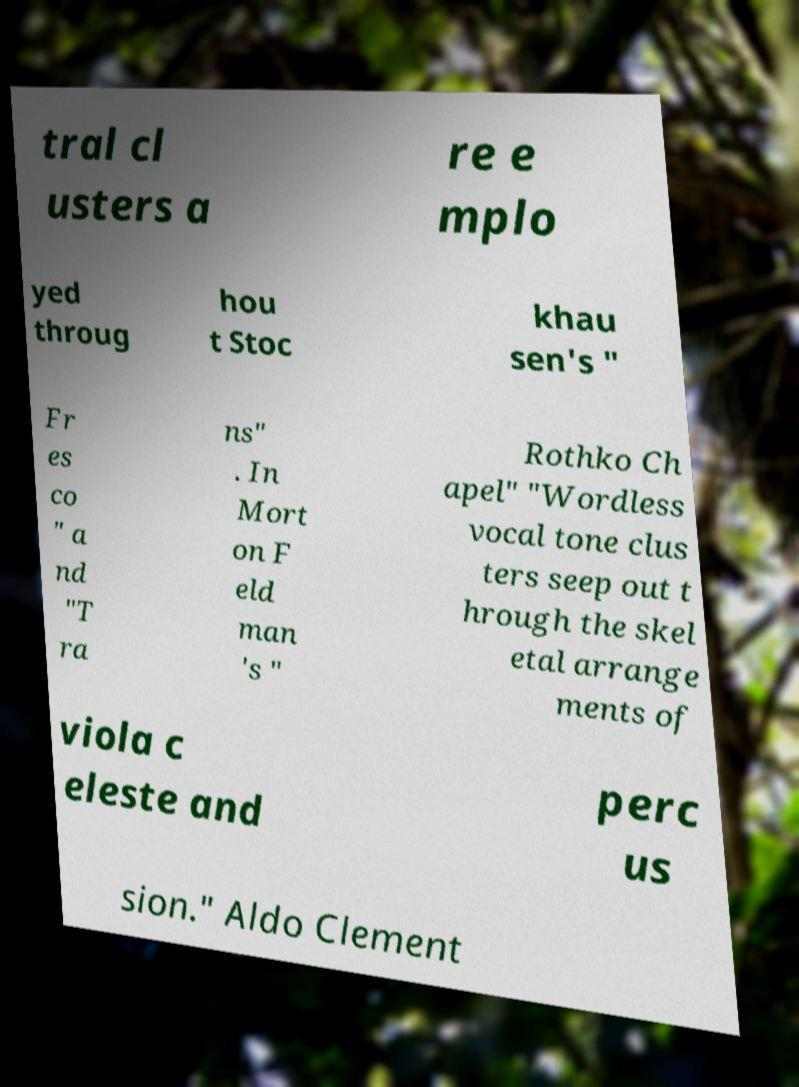Could you assist in decoding the text presented in this image and type it out clearly? tral cl usters a re e mplo yed throug hou t Stoc khau sen's " Fr es co " a nd "T ra ns" . In Mort on F eld man 's " Rothko Ch apel" "Wordless vocal tone clus ters seep out t hrough the skel etal arrange ments of viola c eleste and perc us sion." Aldo Clement 